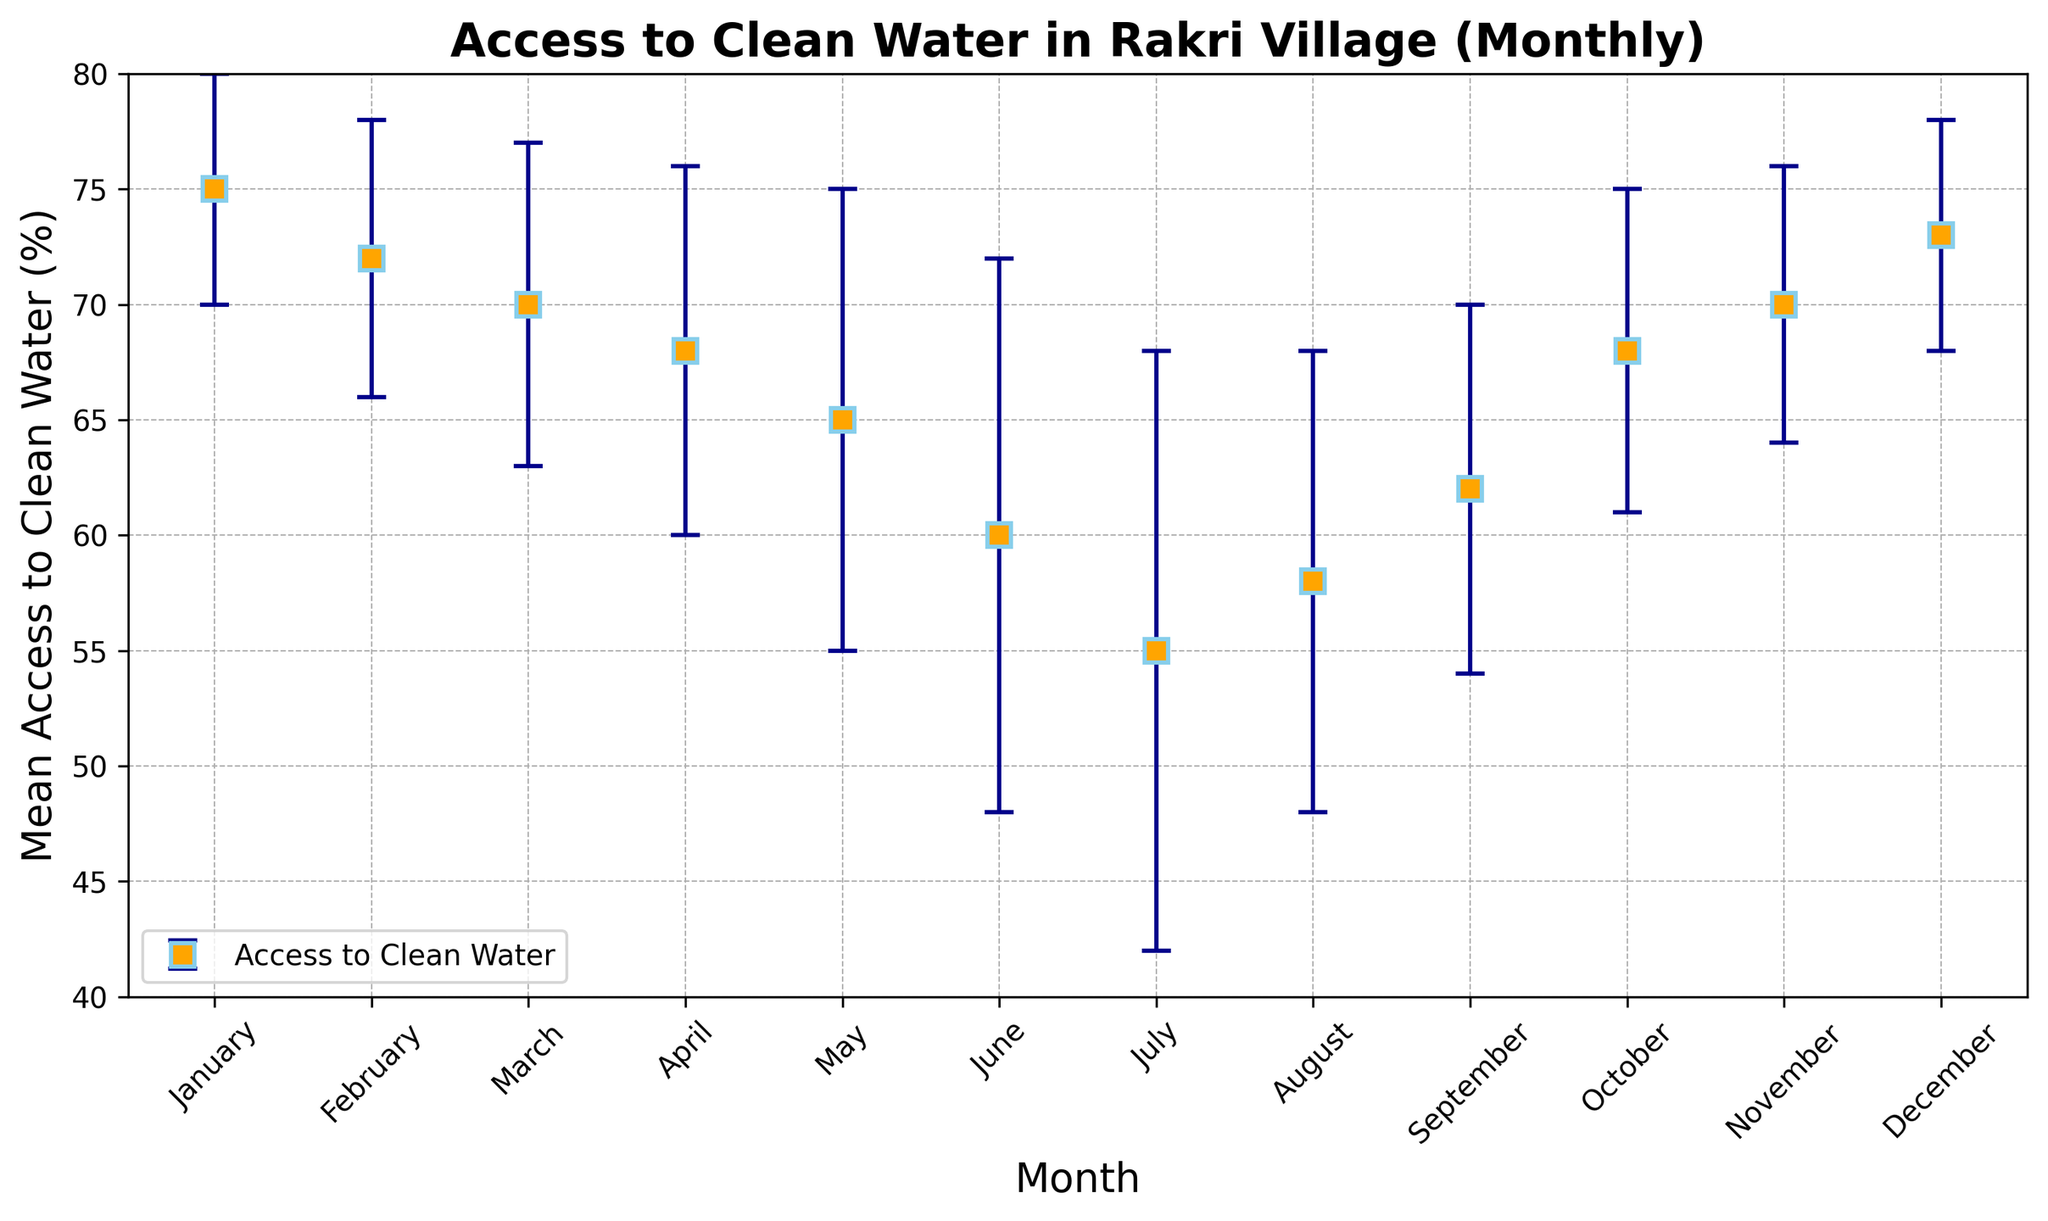What is the range of mean access to clean water across the months? The highest mean value is in January at 75%, and the lowest mean value is in July at 55%. The range is the difference between these two values, 75% - 55%.
Answer: 20% Which month shows the highest variability in access to clean water? The standard deviation represents the variability. The highest standard deviation of 13% is observed in July.
Answer: July Is there a month where the error bars overlap with January's mean access to clean water? January's mean access to clean water is 75% with a standard deviation of 5%, resulting in a range of 70%-80%. Months that overlap with this range include December (mean of 73%, standard deviation of 5%, range of 68%-78%) and November (mean of 70%, standard deviation of 6%, range of 64%-76%).
Answer: December and November Which month marks the lowest mean access to clean water, and what is the corresponding standard deviation? The lowest mean access to clean water is recorded in July, with a mean value of 55% and a standard deviation of 13%.
Answer: July, 13% Considering the transition from July to August, how much does the mean access to clean water increase, and how do their variabilities compare? The mean access to clean water increases from 55% in July to 58% in August, an increase of 3%. The standard deviation decreases from 13% in July to 10% in August, showing reduced variability.
Answer: Increase by 3%, variability decreases by 3% Which months have a higher mean access to clean water than the yearly average, and what are their standard deviations? First, calculate the yearly average: (75% + 72% + 70% + 68% + 65% + 60% + 55% + 58% + 62% + 68% + 70% + 73%) / 12 = 67.33%. The months with higher mean access than 67.33% are January (75%, std 5%), February (72%, std 6%), October (68%, std 7%), November (70%, std 6%), and December (73%, std 5%).
Answer: January (5%), February (6%), October (7%), November (6%), December (5%) Compare the mean access to clean water in January and June. How much lower is June compared to January? January's mean access to clean water is 75%, while June's is 60%, making June's mean 75% - 60% = 15% lower than January's mean.
Answer: 15% How does the access to clean water trend progress from May to September, considering both mean values and standard deviations? From May to September, the mean values are: May (65%), June (60%), July (55%), August (58%), September (62%). The trend shows a decline from May to July, followed by an increase from July to September. The standard deviations are: May (10%), June (12%), July (13%), August (10%), September (8%). Variability is highest in July and gradually decreases towards September.
Answer: Declines from May to July, then rises to September; variability peaks in July and then decreases In which month do we see the second-highest mean access to clean water, and how wide is the confidence interval (mean ± standard deviation) for that month? The second-highest mean access to clean water is in December at 73%. The confidence interval is 73% ± 5%, which is from 68% to 78%.
Answer: December, 68% to 78% How does the mean access to clean water in September compare to October, and what can you infer about the variability between these two months? September's mean is 62%, and October's mean is 68%. The difference is 68% - 62% = 6%, indicating October has higher mean access. The standard deviation for September is 8% and for October is 7%, showing that variability is slightly higher in September compared to October.
Answer: October is 6% higher; September has slightly higher variability 